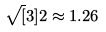Convert formula to latex. <formula><loc_0><loc_0><loc_500><loc_500>\sqrt { [ } 3 ] { 2 } \approx 1 . 2 6</formula> 